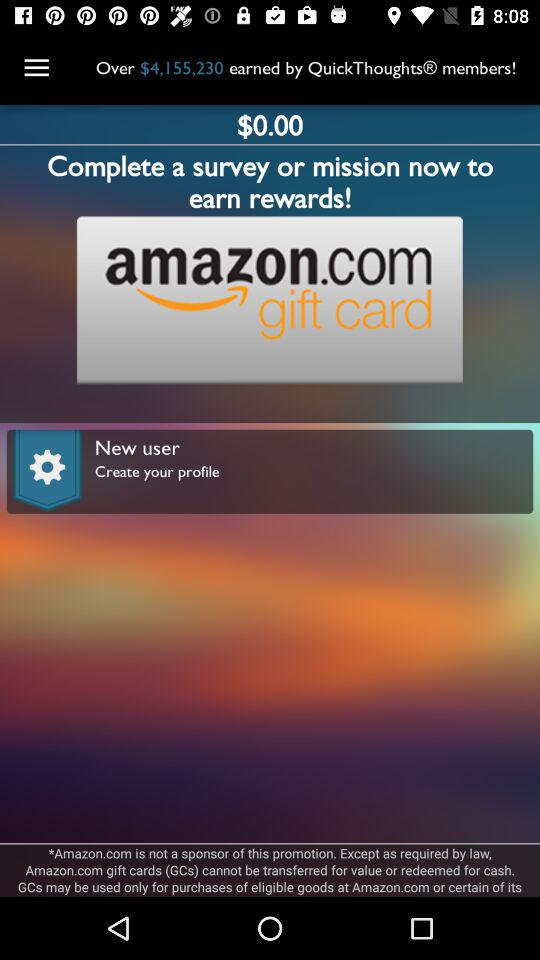How much is the balance in the wallet? The balance in the wallet is $0. 